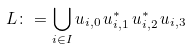<formula> <loc_0><loc_0><loc_500><loc_500>L \colon = \bigcup _ { i \in I } u _ { i , 0 } \, u _ { i , 1 } ^ { \ast } \, u _ { i , 2 } ^ { \ast } \, u _ { i , 3 }</formula> 